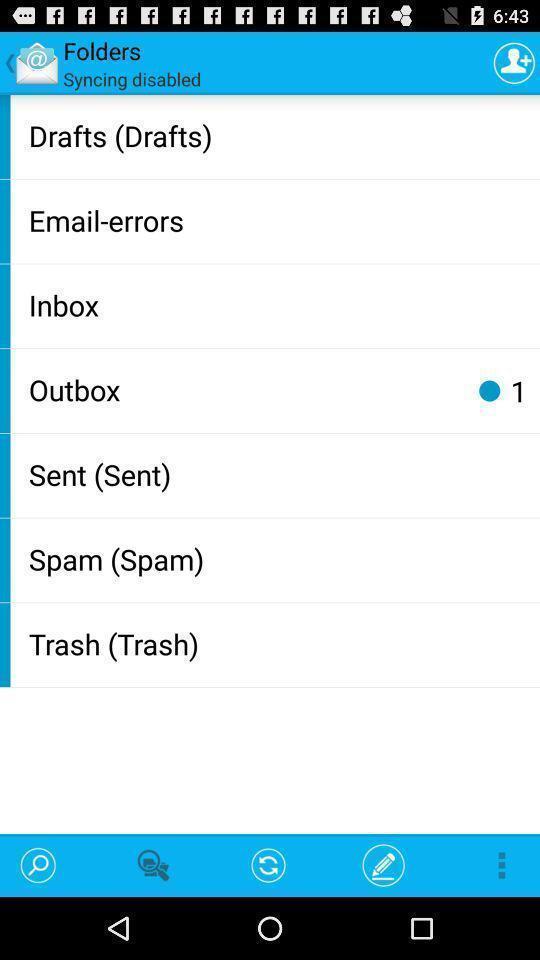Describe this image in words. Page showing folders list with multiple icons like search. 